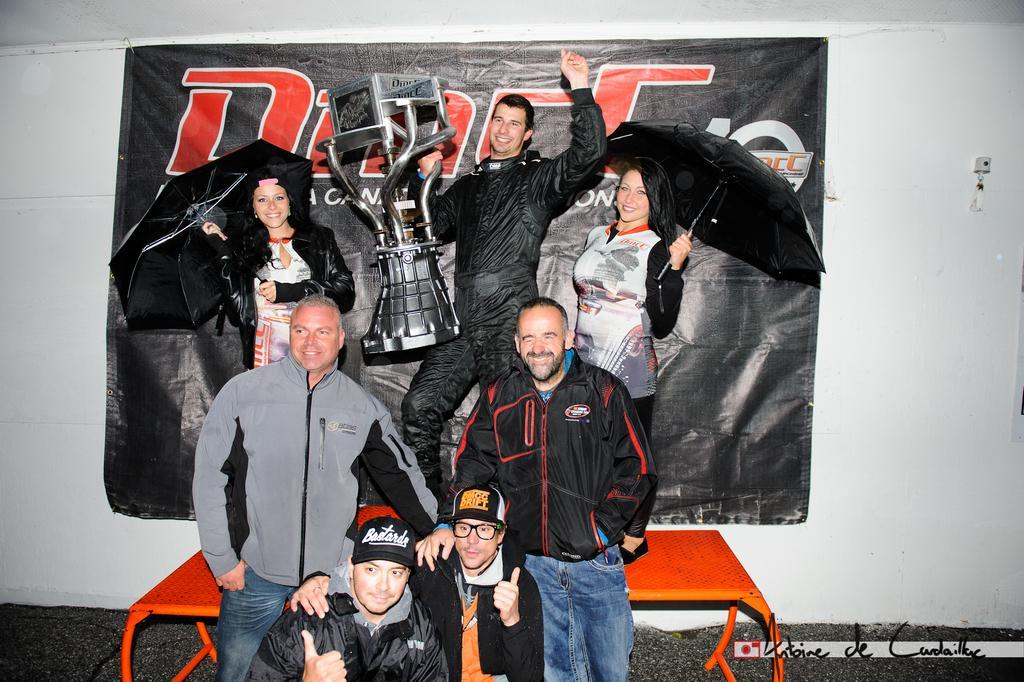In one or two sentences, can you explain what this image depicts? This image is taken indoors. In the background there is a wall and there is a poster with a text on it. At the top of the image there is a ceiling. At the bottom of the image there is a floor. In the middle of the image there is a table and two women and a man are standing on the table. Two women are holding umbrellas in their hands and a man is holding a trophy in his hand. Two men are standing on the floor and two men are sitting on the floor. 